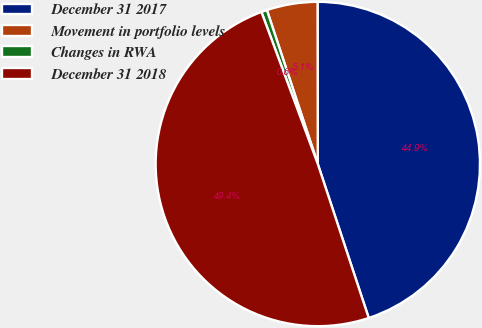Convert chart to OTSL. <chart><loc_0><loc_0><loc_500><loc_500><pie_chart><fcel>December 31 2017<fcel>Movement in portfolio levels<fcel>Changes in RWA<fcel>December 31 2018<nl><fcel>44.94%<fcel>5.06%<fcel>0.57%<fcel>49.43%<nl></chart> 